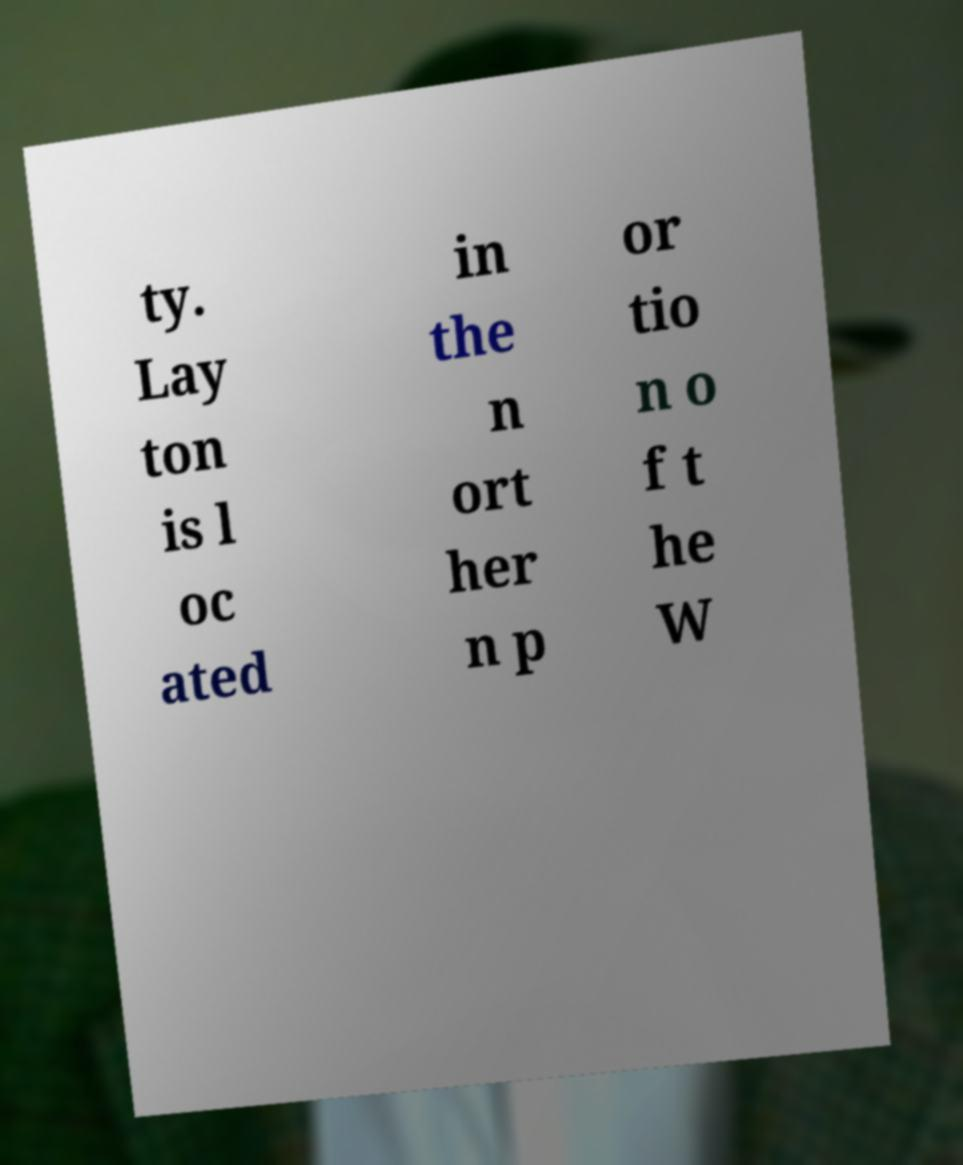For documentation purposes, I need the text within this image transcribed. Could you provide that? ty. Lay ton is l oc ated in the n ort her n p or tio n o f t he W 